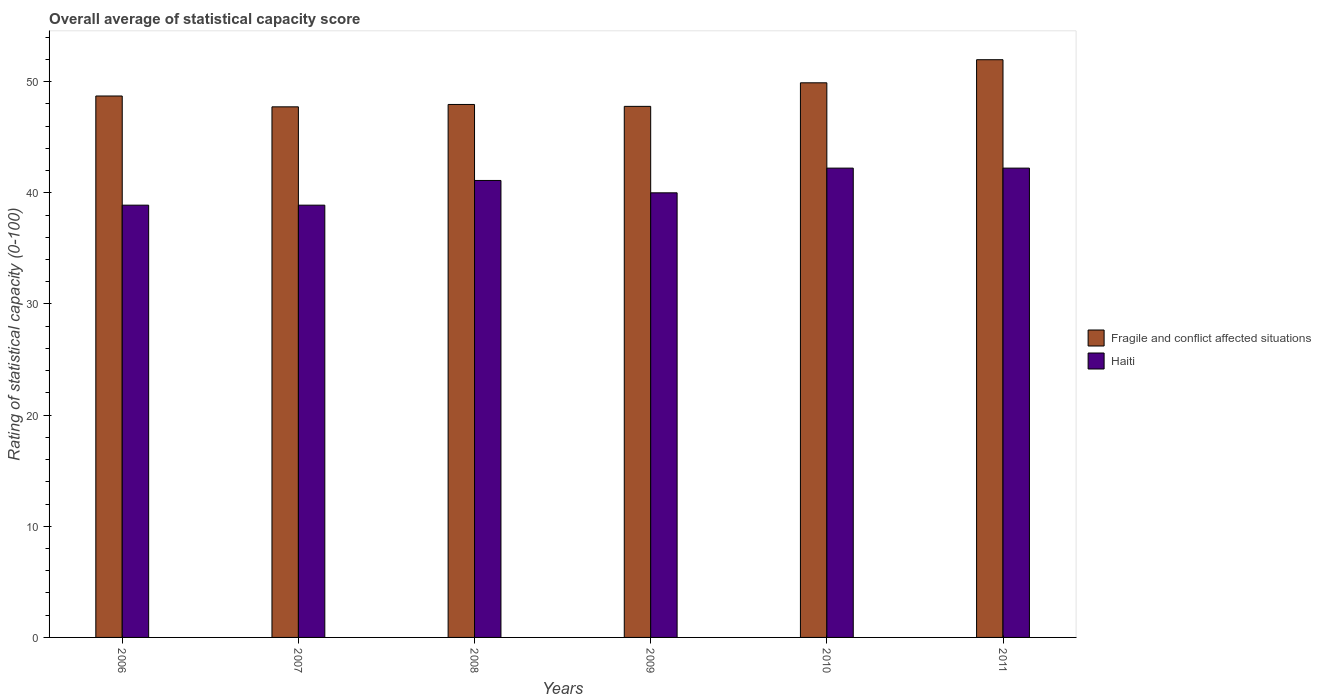How many groups of bars are there?
Your response must be concise. 6. Are the number of bars per tick equal to the number of legend labels?
Give a very brief answer. Yes. In how many cases, is the number of bars for a given year not equal to the number of legend labels?
Your answer should be very brief. 0. What is the rating of statistical capacity in Haiti in 2010?
Ensure brevity in your answer.  42.22. Across all years, what is the maximum rating of statistical capacity in Haiti?
Your response must be concise. 42.22. Across all years, what is the minimum rating of statistical capacity in Haiti?
Give a very brief answer. 38.89. In which year was the rating of statistical capacity in Haiti minimum?
Your response must be concise. 2006. What is the total rating of statistical capacity in Haiti in the graph?
Ensure brevity in your answer.  243.33. What is the difference between the rating of statistical capacity in Fragile and conflict affected situations in 2006 and that in 2009?
Offer a terse response. 0.93. What is the difference between the rating of statistical capacity in Fragile and conflict affected situations in 2010 and the rating of statistical capacity in Haiti in 2006?
Your answer should be very brief. 11.01. What is the average rating of statistical capacity in Fragile and conflict affected situations per year?
Offer a very short reply. 49.01. In the year 2010, what is the difference between the rating of statistical capacity in Fragile and conflict affected situations and rating of statistical capacity in Haiti?
Your answer should be compact. 7.67. In how many years, is the rating of statistical capacity in Fragile and conflict affected situations greater than 18?
Make the answer very short. 6. What is the ratio of the rating of statistical capacity in Fragile and conflict affected situations in 2008 to that in 2011?
Your answer should be compact. 0.92. Is the rating of statistical capacity in Fragile and conflict affected situations in 2008 less than that in 2011?
Make the answer very short. Yes. What is the difference between the highest and the second highest rating of statistical capacity in Fragile and conflict affected situations?
Give a very brief answer. 2.08. What is the difference between the highest and the lowest rating of statistical capacity in Haiti?
Give a very brief answer. 3.33. In how many years, is the rating of statistical capacity in Fragile and conflict affected situations greater than the average rating of statistical capacity in Fragile and conflict affected situations taken over all years?
Your answer should be very brief. 2. What does the 2nd bar from the left in 2011 represents?
Offer a terse response. Haiti. What does the 2nd bar from the right in 2011 represents?
Provide a succinct answer. Fragile and conflict affected situations. How many bars are there?
Provide a short and direct response. 12. Are all the bars in the graph horizontal?
Give a very brief answer. No. How many years are there in the graph?
Ensure brevity in your answer.  6. How many legend labels are there?
Offer a terse response. 2. How are the legend labels stacked?
Make the answer very short. Vertical. What is the title of the graph?
Your answer should be very brief. Overall average of statistical capacity score. Does "Germany" appear as one of the legend labels in the graph?
Ensure brevity in your answer.  No. What is the label or title of the X-axis?
Offer a terse response. Years. What is the label or title of the Y-axis?
Your answer should be very brief. Rating of statistical capacity (0-100). What is the Rating of statistical capacity (0-100) of Fragile and conflict affected situations in 2006?
Provide a succinct answer. 48.71. What is the Rating of statistical capacity (0-100) in Haiti in 2006?
Offer a terse response. 38.89. What is the Rating of statistical capacity (0-100) of Fragile and conflict affected situations in 2007?
Provide a short and direct response. 47.74. What is the Rating of statistical capacity (0-100) in Haiti in 2007?
Provide a succinct answer. 38.89. What is the Rating of statistical capacity (0-100) in Fragile and conflict affected situations in 2008?
Your answer should be very brief. 47.95. What is the Rating of statistical capacity (0-100) in Haiti in 2008?
Provide a short and direct response. 41.11. What is the Rating of statistical capacity (0-100) of Fragile and conflict affected situations in 2009?
Your answer should be compact. 47.78. What is the Rating of statistical capacity (0-100) of Fragile and conflict affected situations in 2010?
Ensure brevity in your answer.  49.9. What is the Rating of statistical capacity (0-100) in Haiti in 2010?
Your response must be concise. 42.22. What is the Rating of statistical capacity (0-100) in Fragile and conflict affected situations in 2011?
Make the answer very short. 51.98. What is the Rating of statistical capacity (0-100) of Haiti in 2011?
Provide a succinct answer. 42.22. Across all years, what is the maximum Rating of statistical capacity (0-100) of Fragile and conflict affected situations?
Provide a succinct answer. 51.98. Across all years, what is the maximum Rating of statistical capacity (0-100) of Haiti?
Your response must be concise. 42.22. Across all years, what is the minimum Rating of statistical capacity (0-100) in Fragile and conflict affected situations?
Provide a succinct answer. 47.74. Across all years, what is the minimum Rating of statistical capacity (0-100) of Haiti?
Provide a short and direct response. 38.89. What is the total Rating of statistical capacity (0-100) in Fragile and conflict affected situations in the graph?
Provide a short and direct response. 294.05. What is the total Rating of statistical capacity (0-100) in Haiti in the graph?
Provide a short and direct response. 243.33. What is the difference between the Rating of statistical capacity (0-100) of Fragile and conflict affected situations in 2006 and that in 2007?
Your response must be concise. 0.98. What is the difference between the Rating of statistical capacity (0-100) of Haiti in 2006 and that in 2007?
Your answer should be very brief. 0. What is the difference between the Rating of statistical capacity (0-100) of Fragile and conflict affected situations in 2006 and that in 2008?
Give a very brief answer. 0.76. What is the difference between the Rating of statistical capacity (0-100) in Haiti in 2006 and that in 2008?
Your answer should be compact. -2.22. What is the difference between the Rating of statistical capacity (0-100) in Haiti in 2006 and that in 2009?
Your response must be concise. -1.11. What is the difference between the Rating of statistical capacity (0-100) in Fragile and conflict affected situations in 2006 and that in 2010?
Your answer should be very brief. -1.19. What is the difference between the Rating of statistical capacity (0-100) in Haiti in 2006 and that in 2010?
Offer a terse response. -3.33. What is the difference between the Rating of statistical capacity (0-100) in Fragile and conflict affected situations in 2006 and that in 2011?
Offer a terse response. -3.26. What is the difference between the Rating of statistical capacity (0-100) in Haiti in 2006 and that in 2011?
Keep it short and to the point. -3.33. What is the difference between the Rating of statistical capacity (0-100) of Fragile and conflict affected situations in 2007 and that in 2008?
Ensure brevity in your answer.  -0.21. What is the difference between the Rating of statistical capacity (0-100) in Haiti in 2007 and that in 2008?
Your answer should be very brief. -2.22. What is the difference between the Rating of statistical capacity (0-100) in Fragile and conflict affected situations in 2007 and that in 2009?
Provide a short and direct response. -0.04. What is the difference between the Rating of statistical capacity (0-100) of Haiti in 2007 and that in 2009?
Your answer should be very brief. -1.11. What is the difference between the Rating of statistical capacity (0-100) of Fragile and conflict affected situations in 2007 and that in 2010?
Your answer should be very brief. -2.16. What is the difference between the Rating of statistical capacity (0-100) in Fragile and conflict affected situations in 2007 and that in 2011?
Make the answer very short. -4.24. What is the difference between the Rating of statistical capacity (0-100) in Haiti in 2007 and that in 2011?
Offer a very short reply. -3.33. What is the difference between the Rating of statistical capacity (0-100) of Fragile and conflict affected situations in 2008 and that in 2009?
Provide a short and direct response. 0.17. What is the difference between the Rating of statistical capacity (0-100) of Fragile and conflict affected situations in 2008 and that in 2010?
Make the answer very short. -1.95. What is the difference between the Rating of statistical capacity (0-100) of Haiti in 2008 and that in 2010?
Your answer should be compact. -1.11. What is the difference between the Rating of statistical capacity (0-100) in Fragile and conflict affected situations in 2008 and that in 2011?
Your answer should be very brief. -4.03. What is the difference between the Rating of statistical capacity (0-100) in Haiti in 2008 and that in 2011?
Ensure brevity in your answer.  -1.11. What is the difference between the Rating of statistical capacity (0-100) of Fragile and conflict affected situations in 2009 and that in 2010?
Give a very brief answer. -2.12. What is the difference between the Rating of statistical capacity (0-100) of Haiti in 2009 and that in 2010?
Offer a terse response. -2.22. What is the difference between the Rating of statistical capacity (0-100) of Fragile and conflict affected situations in 2009 and that in 2011?
Provide a short and direct response. -4.2. What is the difference between the Rating of statistical capacity (0-100) of Haiti in 2009 and that in 2011?
Offer a terse response. -2.22. What is the difference between the Rating of statistical capacity (0-100) in Fragile and conflict affected situations in 2010 and that in 2011?
Ensure brevity in your answer.  -2.08. What is the difference between the Rating of statistical capacity (0-100) of Fragile and conflict affected situations in 2006 and the Rating of statistical capacity (0-100) of Haiti in 2007?
Provide a short and direct response. 9.82. What is the difference between the Rating of statistical capacity (0-100) of Fragile and conflict affected situations in 2006 and the Rating of statistical capacity (0-100) of Haiti in 2008?
Offer a very short reply. 7.6. What is the difference between the Rating of statistical capacity (0-100) in Fragile and conflict affected situations in 2006 and the Rating of statistical capacity (0-100) in Haiti in 2009?
Your response must be concise. 8.71. What is the difference between the Rating of statistical capacity (0-100) of Fragile and conflict affected situations in 2006 and the Rating of statistical capacity (0-100) of Haiti in 2010?
Make the answer very short. 6.49. What is the difference between the Rating of statistical capacity (0-100) in Fragile and conflict affected situations in 2006 and the Rating of statistical capacity (0-100) in Haiti in 2011?
Your answer should be very brief. 6.49. What is the difference between the Rating of statistical capacity (0-100) of Fragile and conflict affected situations in 2007 and the Rating of statistical capacity (0-100) of Haiti in 2008?
Your answer should be very brief. 6.62. What is the difference between the Rating of statistical capacity (0-100) of Fragile and conflict affected situations in 2007 and the Rating of statistical capacity (0-100) of Haiti in 2009?
Offer a terse response. 7.74. What is the difference between the Rating of statistical capacity (0-100) of Fragile and conflict affected situations in 2007 and the Rating of statistical capacity (0-100) of Haiti in 2010?
Keep it short and to the point. 5.51. What is the difference between the Rating of statistical capacity (0-100) in Fragile and conflict affected situations in 2007 and the Rating of statistical capacity (0-100) in Haiti in 2011?
Offer a terse response. 5.51. What is the difference between the Rating of statistical capacity (0-100) of Fragile and conflict affected situations in 2008 and the Rating of statistical capacity (0-100) of Haiti in 2009?
Make the answer very short. 7.95. What is the difference between the Rating of statistical capacity (0-100) of Fragile and conflict affected situations in 2008 and the Rating of statistical capacity (0-100) of Haiti in 2010?
Offer a terse response. 5.73. What is the difference between the Rating of statistical capacity (0-100) in Fragile and conflict affected situations in 2008 and the Rating of statistical capacity (0-100) in Haiti in 2011?
Provide a short and direct response. 5.73. What is the difference between the Rating of statistical capacity (0-100) of Fragile and conflict affected situations in 2009 and the Rating of statistical capacity (0-100) of Haiti in 2010?
Give a very brief answer. 5.56. What is the difference between the Rating of statistical capacity (0-100) of Fragile and conflict affected situations in 2009 and the Rating of statistical capacity (0-100) of Haiti in 2011?
Offer a very short reply. 5.56. What is the difference between the Rating of statistical capacity (0-100) in Fragile and conflict affected situations in 2010 and the Rating of statistical capacity (0-100) in Haiti in 2011?
Offer a very short reply. 7.67. What is the average Rating of statistical capacity (0-100) of Fragile and conflict affected situations per year?
Offer a terse response. 49.01. What is the average Rating of statistical capacity (0-100) in Haiti per year?
Provide a short and direct response. 40.56. In the year 2006, what is the difference between the Rating of statistical capacity (0-100) in Fragile and conflict affected situations and Rating of statistical capacity (0-100) in Haiti?
Provide a short and direct response. 9.82. In the year 2007, what is the difference between the Rating of statistical capacity (0-100) of Fragile and conflict affected situations and Rating of statistical capacity (0-100) of Haiti?
Offer a terse response. 8.85. In the year 2008, what is the difference between the Rating of statistical capacity (0-100) of Fragile and conflict affected situations and Rating of statistical capacity (0-100) of Haiti?
Your answer should be compact. 6.84. In the year 2009, what is the difference between the Rating of statistical capacity (0-100) in Fragile and conflict affected situations and Rating of statistical capacity (0-100) in Haiti?
Provide a succinct answer. 7.78. In the year 2010, what is the difference between the Rating of statistical capacity (0-100) in Fragile and conflict affected situations and Rating of statistical capacity (0-100) in Haiti?
Your answer should be very brief. 7.67. In the year 2011, what is the difference between the Rating of statistical capacity (0-100) of Fragile and conflict affected situations and Rating of statistical capacity (0-100) of Haiti?
Your answer should be compact. 9.75. What is the ratio of the Rating of statistical capacity (0-100) of Fragile and conflict affected situations in 2006 to that in 2007?
Offer a very short reply. 1.02. What is the ratio of the Rating of statistical capacity (0-100) in Haiti in 2006 to that in 2007?
Your response must be concise. 1. What is the ratio of the Rating of statistical capacity (0-100) in Fragile and conflict affected situations in 2006 to that in 2008?
Your response must be concise. 1.02. What is the ratio of the Rating of statistical capacity (0-100) of Haiti in 2006 to that in 2008?
Offer a very short reply. 0.95. What is the ratio of the Rating of statistical capacity (0-100) in Fragile and conflict affected situations in 2006 to that in 2009?
Offer a terse response. 1.02. What is the ratio of the Rating of statistical capacity (0-100) in Haiti in 2006 to that in 2009?
Provide a succinct answer. 0.97. What is the ratio of the Rating of statistical capacity (0-100) of Fragile and conflict affected situations in 2006 to that in 2010?
Ensure brevity in your answer.  0.98. What is the ratio of the Rating of statistical capacity (0-100) of Haiti in 2006 to that in 2010?
Offer a terse response. 0.92. What is the ratio of the Rating of statistical capacity (0-100) in Fragile and conflict affected situations in 2006 to that in 2011?
Provide a short and direct response. 0.94. What is the ratio of the Rating of statistical capacity (0-100) of Haiti in 2006 to that in 2011?
Ensure brevity in your answer.  0.92. What is the ratio of the Rating of statistical capacity (0-100) in Fragile and conflict affected situations in 2007 to that in 2008?
Ensure brevity in your answer.  1. What is the ratio of the Rating of statistical capacity (0-100) in Haiti in 2007 to that in 2008?
Your answer should be compact. 0.95. What is the ratio of the Rating of statistical capacity (0-100) of Haiti in 2007 to that in 2009?
Make the answer very short. 0.97. What is the ratio of the Rating of statistical capacity (0-100) in Fragile and conflict affected situations in 2007 to that in 2010?
Keep it short and to the point. 0.96. What is the ratio of the Rating of statistical capacity (0-100) in Haiti in 2007 to that in 2010?
Your answer should be compact. 0.92. What is the ratio of the Rating of statistical capacity (0-100) in Fragile and conflict affected situations in 2007 to that in 2011?
Offer a terse response. 0.92. What is the ratio of the Rating of statistical capacity (0-100) in Haiti in 2007 to that in 2011?
Offer a very short reply. 0.92. What is the ratio of the Rating of statistical capacity (0-100) of Fragile and conflict affected situations in 2008 to that in 2009?
Your response must be concise. 1. What is the ratio of the Rating of statistical capacity (0-100) in Haiti in 2008 to that in 2009?
Your answer should be very brief. 1.03. What is the ratio of the Rating of statistical capacity (0-100) of Haiti in 2008 to that in 2010?
Your answer should be very brief. 0.97. What is the ratio of the Rating of statistical capacity (0-100) in Fragile and conflict affected situations in 2008 to that in 2011?
Provide a succinct answer. 0.92. What is the ratio of the Rating of statistical capacity (0-100) of Haiti in 2008 to that in 2011?
Your answer should be very brief. 0.97. What is the ratio of the Rating of statistical capacity (0-100) in Fragile and conflict affected situations in 2009 to that in 2010?
Give a very brief answer. 0.96. What is the ratio of the Rating of statistical capacity (0-100) in Fragile and conflict affected situations in 2009 to that in 2011?
Provide a short and direct response. 0.92. What is the ratio of the Rating of statistical capacity (0-100) in Haiti in 2009 to that in 2011?
Offer a very short reply. 0.95. What is the difference between the highest and the second highest Rating of statistical capacity (0-100) in Fragile and conflict affected situations?
Offer a terse response. 2.08. What is the difference between the highest and the lowest Rating of statistical capacity (0-100) of Fragile and conflict affected situations?
Provide a short and direct response. 4.24. What is the difference between the highest and the lowest Rating of statistical capacity (0-100) of Haiti?
Provide a short and direct response. 3.33. 